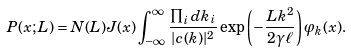<formula> <loc_0><loc_0><loc_500><loc_500>P ( x ; L ) & = N ( L ) J ( x ) \int _ { - \infty } ^ { \infty } \frac { \prod _ { i } d k _ { i } } { | c ( k ) | ^ { 2 } } \exp \left ( - \frac { L k ^ { 2 } } { 2 \gamma \ell } \right ) \varphi _ { k } ( x ) .</formula> 